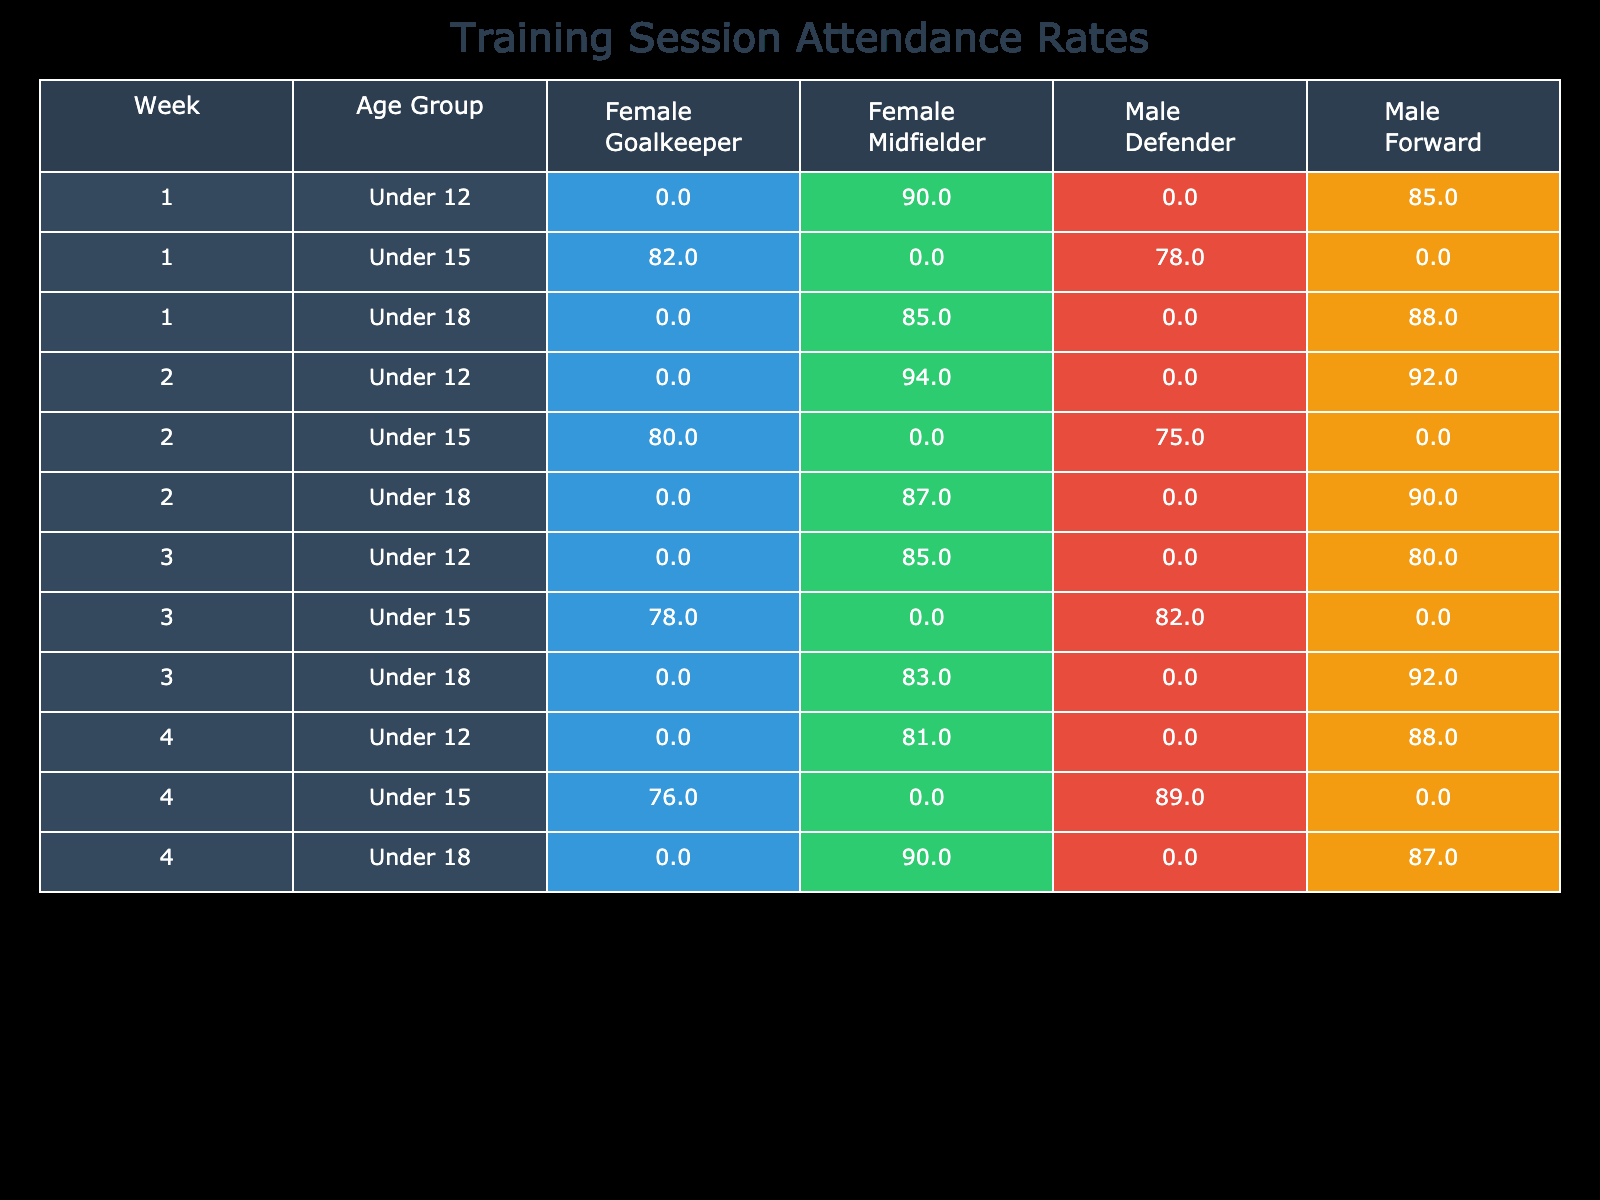What was the attendance rate for Male Under 12 Forwards in Week 3? In Week 3, the attendance rate for Male Under 12 Forwards is 80, as observed directly in the table.
Answer: 80 What is the maximum attendance rate for Female Under 15 players across all weeks? By examining the attendance rates for Female Under 15 players, the highest attendance rate appears in Week 1, which is 82.
Answer: 82 Did Male Under 18 Midfielders have a consistent attendance rate each week? By comparing the attendance rates for Male Under 18 Midfielders, we can see the rates were 85 in Week 1, 87 in Week 2, 83 in Week 3, and 90 in Week 4, showing they did not have a consistent rate as the values changed.
Answer: No What is the total attendance rate for Female Midfielders over all four weeks? The attendance rates for Female Midfielders are as follows: Week 1 has 90, Week 2 has 94, Week 3 has 85, and Week 4 has 81. Summing these values gives 90 + 94 + 85 + 81 = 350.
Answer: 350 What was the average attendance rate for Male Defenders over the four weeks? The attendance rates for Male Defenders are 78 (Week 1), 75 (Week 2), 82 (Week 3), and 89 (Week 4). Summing these gives 78 + 75 + 82 + 89 = 324, and dividing by 4 gives an average of 324 / 4 = 81.
Answer: 81 Is there any week where Female Goalkeepers had an attendance rate greater than 80? Looking at the attendance rates for Female Goalkeepers, we can see Week 1 has 82 and Week 2 has 80. Week 3 has 78 and Week 4 has 76, meaning there are two weeks (Week 1 and Week 2) with rates above 80.
Answer: Yes What was the attendance rate for Male Under 12 players in Week 1 compared to Week 4? In Week 1, the attendance rate for Male Under 12 players is 85, and in Week 4 it is 88. Comparing these values shows that Week 4 had a higher attendance rate by 3 points (88 - 85 = 3).
Answer: Week 4 is higher by 3 points Which player demographic had the highest attendance rate overall in Week 2? In Week 2, the maximum attendance rate is from Female Under 12 Midfielders at 94, observed from the table. Other values in Week 2 are lower than this.
Answer: Female Under 12 Midfielders at 94 